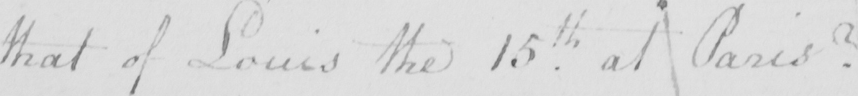Transcribe the text shown in this historical manuscript line. that of Louis the 15th at Paris ? 